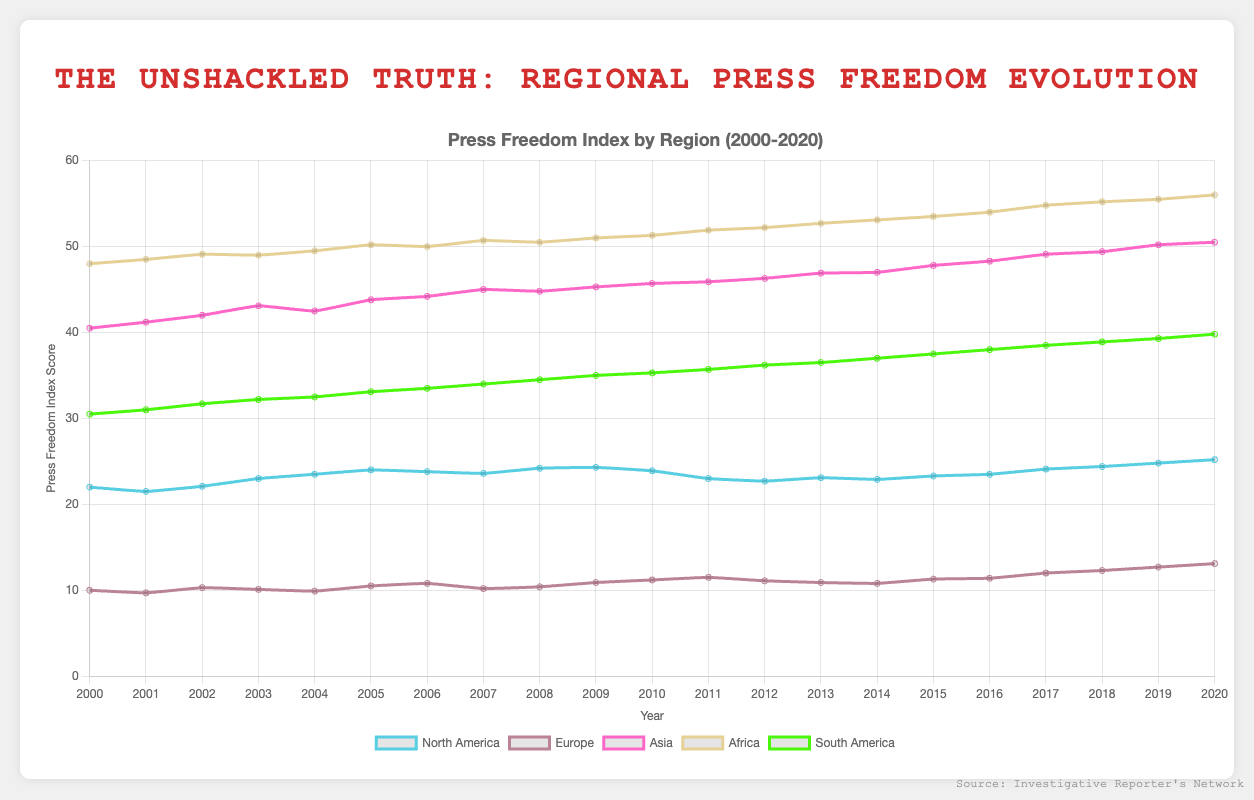What was the trend in the press freedom index for North America from 2000 to 2020? Over the years, North America's press freedom index exhibited a general upward trend, starting at 22.0 in 2000 and rising to 25.2 in 2020. This implies that press freedom slightly worsened over the two decades, as higher index scores indicate less press freedom.
Answer: Upward trend Which region had the lowest press freedom index score in 2020? To find the lowest score for 2020, examine the index scores for all regions in that year. Europe had the lowest index score of 13.1 in 2020, indicating the highest level of press freedom among the regions during that year.
Answer: Europe How did the press freedom index for Asia change from 2000 to 2020? Analyzing the scores for Asia from 2000 to 2020, Asia's index increased from 40.5 to 50.5. This indicates a decline in press freedom over the two decades, as higher values signify lower press freedom.
Answer: Increased Is North America's press freedom index in 2020 higher or lower than in 2005? The index for North America in 2020 is 25.2, while in 2005, it was 24.0. Comparing these figures shows that the 2020 score is higher, indicating reduced press freedom.
Answer: Higher Which region showed the most significant increase in its press freedom index from 2000 to 2020? To determine the most significant increase, compute the difference in index scores for each region from 2000 to 2020. The increases are: North America (3.2), Europe (3.1), Asia (10.0), Africa (8.0), and South America (9.3). Asia had the highest increase of 10.0, indicating the greatest decline in press freedom.
Answer: Asia What is the arithmetic mean of the press freedom index scores for South America in 2000 and 2020? To find the arithmetic mean, add the scores for South America in 2000 and 2020, then divide by 2: (30.5 + 39.8) / 2 = 35.15.
Answer: 35.15 Compare the visual height of the line representing Africa to that of Europe in 2020. Which is higher? In the line plot, the visual height is proportional to the score. The score for Africa in 2020 is 56.0, while for Europe, it is 13.1. Therefore, the line representing Africa is visually higher on the chart compared to Europe.
Answer: Africa How many regions had their press freedom index score worsened (increased) from 2019 to 2020? Compare the scores from 2019 to 2020 for each region: North America (24.8 to 25.2), Europe (12.7 to 13.1), Asia (50.2 to 50.5), Africa (55.5 to 56.0), and South America (39.3 to 39.8). All regions show an increased score, indicating worsened press freedom.
Answer: 5 Combine and average the press freedom index scores for Europe, Asia, and Africa in 2005. First, sum the scores for Europe (10.5), Asia (43.8), and Africa (50.2), then divide by 3: (10.5 + 43.8 + 50.2) / 3 = 34.83 (rounded to 2 decimal places).
Answer: 34.83 